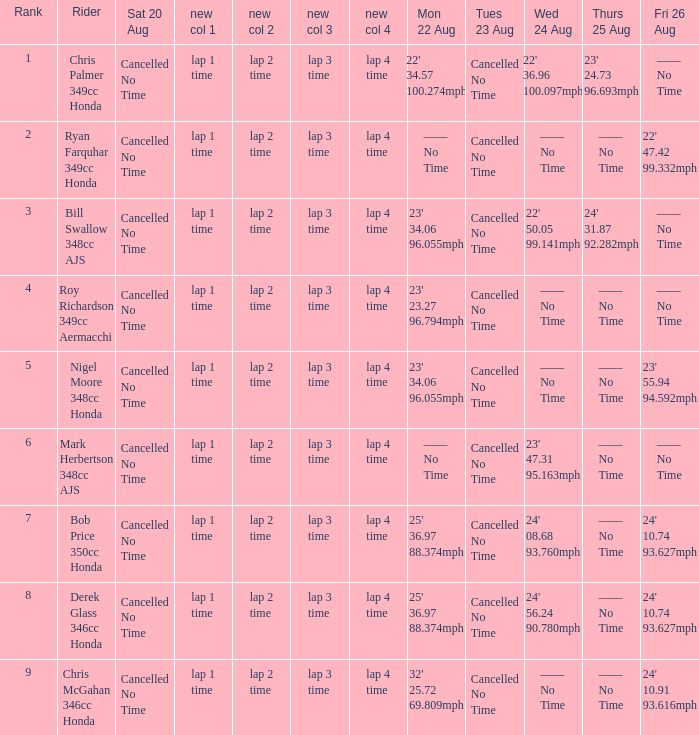What is every entry on Monday August 22 when the entry for Wednesday August 24 is 22' 50.05 99.141mph? 23' 34.06 96.055mph. 